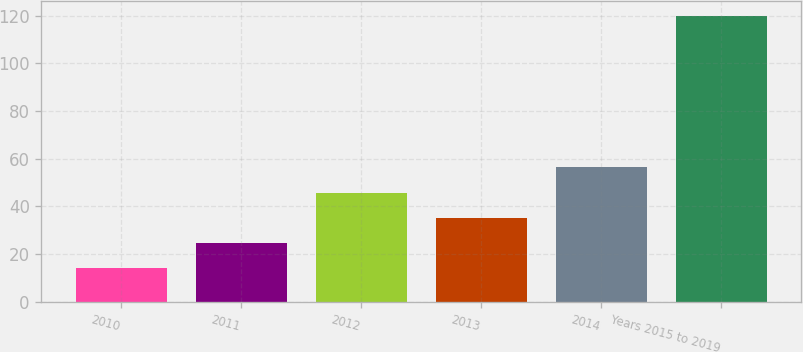Convert chart to OTSL. <chart><loc_0><loc_0><loc_500><loc_500><bar_chart><fcel>2010<fcel>2011<fcel>2012<fcel>2013<fcel>2014<fcel>Years 2015 to 2019<nl><fcel>14<fcel>24.6<fcel>45.8<fcel>35.2<fcel>56.4<fcel>120<nl></chart> 